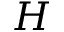Convert formula to latex. <formula><loc_0><loc_0><loc_500><loc_500>H</formula> 